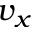<formula> <loc_0><loc_0><loc_500><loc_500>v _ { x }</formula> 